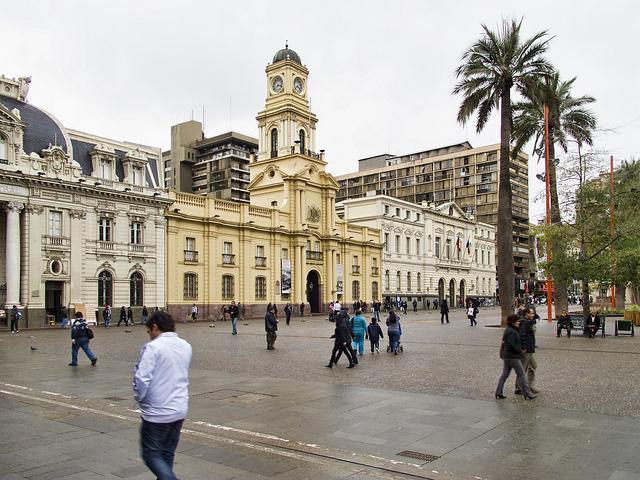What location are people strolling in?
Choose the right answer from the provided options to respond to the question.
Options: Mall shops, race track, bazaar, plaza. Plaza. 